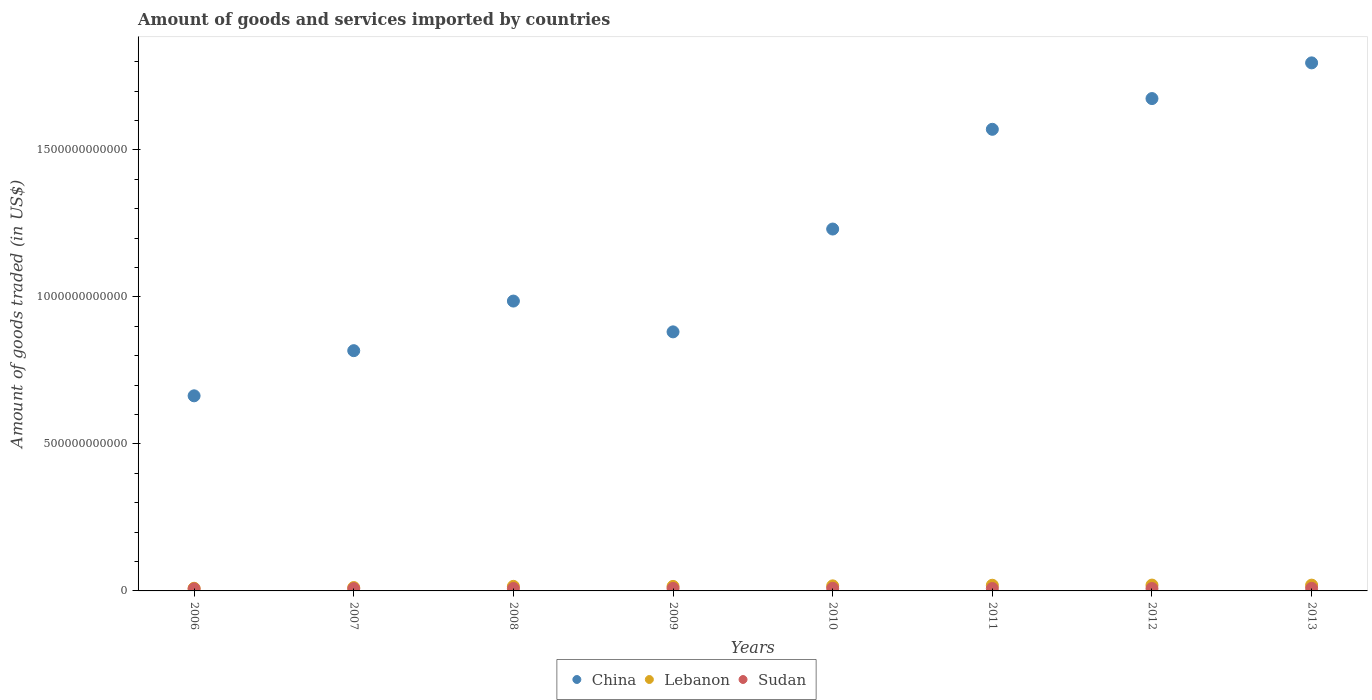How many different coloured dotlines are there?
Your answer should be very brief. 3. Is the number of dotlines equal to the number of legend labels?
Keep it short and to the point. Yes. What is the total amount of goods and services imported in Sudan in 2007?
Make the answer very short. 7.72e+09. Across all years, what is the maximum total amount of goods and services imported in Sudan?
Your response must be concise. 8.84e+09. Across all years, what is the minimum total amount of goods and services imported in Lebanon?
Your answer should be very brief. 9.03e+09. In which year was the total amount of goods and services imported in Lebanon minimum?
Offer a very short reply. 2006. What is the total total amount of goods and services imported in China in the graph?
Provide a succinct answer. 9.62e+12. What is the difference between the total amount of goods and services imported in China in 2010 and that in 2013?
Provide a short and direct response. -5.65e+11. What is the difference between the total amount of goods and services imported in China in 2009 and the total amount of goods and services imported in Sudan in 2008?
Your answer should be very brief. 8.73e+11. What is the average total amount of goods and services imported in Lebanon per year?
Keep it short and to the point. 1.59e+1. In the year 2006, what is the difference between the total amount of goods and services imported in Lebanon and total amount of goods and services imported in China?
Keep it short and to the point. -6.54e+11. In how many years, is the total amount of goods and services imported in Sudan greater than 600000000000 US$?
Make the answer very short. 0. What is the ratio of the total amount of goods and services imported in Lebanon in 2010 to that in 2012?
Your response must be concise. 0.87. Is the total amount of goods and services imported in Sudan in 2011 less than that in 2012?
Your response must be concise. No. What is the difference between the highest and the second highest total amount of goods and services imported in Lebanon?
Offer a very short reply. 1.67e+08. What is the difference between the highest and the lowest total amount of goods and services imported in China?
Offer a terse response. 1.13e+12. In how many years, is the total amount of goods and services imported in China greater than the average total amount of goods and services imported in China taken over all years?
Keep it short and to the point. 4. Is the sum of the total amount of goods and services imported in Lebanon in 2009 and 2011 greater than the maximum total amount of goods and services imported in China across all years?
Keep it short and to the point. No. Is it the case that in every year, the sum of the total amount of goods and services imported in China and total amount of goods and services imported in Lebanon  is greater than the total amount of goods and services imported in Sudan?
Offer a terse response. Yes. Does the total amount of goods and services imported in China monotonically increase over the years?
Make the answer very short. No. Is the total amount of goods and services imported in Lebanon strictly less than the total amount of goods and services imported in China over the years?
Provide a succinct answer. Yes. How many dotlines are there?
Provide a short and direct response. 3. How many years are there in the graph?
Your answer should be very brief. 8. What is the difference between two consecutive major ticks on the Y-axis?
Your response must be concise. 5.00e+11. Does the graph contain any zero values?
Keep it short and to the point. No. How many legend labels are there?
Your answer should be compact. 3. What is the title of the graph?
Your answer should be compact. Amount of goods and services imported by countries. Does "Maldives" appear as one of the legend labels in the graph?
Provide a succinct answer. No. What is the label or title of the Y-axis?
Your response must be concise. Amount of goods traded (in US$). What is the Amount of goods traded (in US$) of China in 2006?
Give a very brief answer. 6.64e+11. What is the Amount of goods traded (in US$) of Lebanon in 2006?
Your answer should be very brief. 9.03e+09. What is the Amount of goods traded (in US$) in Sudan in 2006?
Ensure brevity in your answer.  7.10e+09. What is the Amount of goods traded (in US$) of China in 2007?
Your answer should be compact. 8.17e+11. What is the Amount of goods traded (in US$) of Lebanon in 2007?
Your answer should be compact. 1.15e+1. What is the Amount of goods traded (in US$) of Sudan in 2007?
Your answer should be compact. 7.72e+09. What is the Amount of goods traded (in US$) in China in 2008?
Ensure brevity in your answer.  9.86e+11. What is the Amount of goods traded (in US$) of Lebanon in 2008?
Offer a very short reply. 1.55e+1. What is the Amount of goods traded (in US$) in Sudan in 2008?
Offer a very short reply. 8.23e+09. What is the Amount of goods traded (in US$) of China in 2009?
Your answer should be compact. 8.81e+11. What is the Amount of goods traded (in US$) in Lebanon in 2009?
Your response must be concise. 1.54e+1. What is the Amount of goods traded (in US$) in Sudan in 2009?
Your answer should be compact. 8.53e+09. What is the Amount of goods traded (in US$) in China in 2010?
Your response must be concise. 1.23e+12. What is the Amount of goods traded (in US$) in Lebanon in 2010?
Give a very brief answer. 1.72e+1. What is the Amount of goods traded (in US$) in Sudan in 2010?
Ensure brevity in your answer.  8.84e+09. What is the Amount of goods traded (in US$) in China in 2011?
Make the answer very short. 1.57e+12. What is the Amount of goods traded (in US$) of Lebanon in 2011?
Provide a short and direct response. 1.93e+1. What is the Amount of goods traded (in US$) of Sudan in 2011?
Your answer should be very brief. 8.13e+09. What is the Amount of goods traded (in US$) in China in 2012?
Give a very brief answer. 1.67e+12. What is the Amount of goods traded (in US$) of Lebanon in 2012?
Provide a short and direct response. 1.98e+1. What is the Amount of goods traded (in US$) of Sudan in 2012?
Offer a terse response. 8.12e+09. What is the Amount of goods traded (in US$) of China in 2013?
Your response must be concise. 1.80e+12. What is the Amount of goods traded (in US$) in Lebanon in 2013?
Offer a terse response. 1.97e+1. What is the Amount of goods traded (in US$) in Sudan in 2013?
Your answer should be very brief. 8.73e+09. Across all years, what is the maximum Amount of goods traded (in US$) of China?
Provide a succinct answer. 1.80e+12. Across all years, what is the maximum Amount of goods traded (in US$) in Lebanon?
Provide a short and direct response. 1.98e+1. Across all years, what is the maximum Amount of goods traded (in US$) of Sudan?
Provide a short and direct response. 8.84e+09. Across all years, what is the minimum Amount of goods traded (in US$) of China?
Make the answer very short. 6.64e+11. Across all years, what is the minimum Amount of goods traded (in US$) in Lebanon?
Provide a short and direct response. 9.03e+09. Across all years, what is the minimum Amount of goods traded (in US$) of Sudan?
Offer a very short reply. 7.10e+09. What is the total Amount of goods traded (in US$) in China in the graph?
Give a very brief answer. 9.62e+12. What is the total Amount of goods traded (in US$) in Lebanon in the graph?
Offer a very short reply. 1.27e+11. What is the total Amount of goods traded (in US$) in Sudan in the graph?
Your response must be concise. 6.54e+1. What is the difference between the Amount of goods traded (in US$) of China in 2006 and that in 2007?
Your answer should be very brief. -1.54e+11. What is the difference between the Amount of goods traded (in US$) in Lebanon in 2006 and that in 2007?
Keep it short and to the point. -2.44e+09. What is the difference between the Amount of goods traded (in US$) of Sudan in 2006 and that in 2007?
Provide a short and direct response. -6.18e+08. What is the difference between the Amount of goods traded (in US$) in China in 2006 and that in 2008?
Give a very brief answer. -3.22e+11. What is the difference between the Amount of goods traded (in US$) in Lebanon in 2006 and that in 2008?
Provide a short and direct response. -6.51e+09. What is the difference between the Amount of goods traded (in US$) in Sudan in 2006 and that in 2008?
Offer a terse response. -1.12e+09. What is the difference between the Amount of goods traded (in US$) of China in 2006 and that in 2009?
Provide a succinct answer. -2.17e+11. What is the difference between the Amount of goods traded (in US$) of Lebanon in 2006 and that in 2009?
Provide a short and direct response. -6.37e+09. What is the difference between the Amount of goods traded (in US$) of Sudan in 2006 and that in 2009?
Offer a very short reply. -1.42e+09. What is the difference between the Amount of goods traded (in US$) of China in 2006 and that in 2010?
Ensure brevity in your answer.  -5.67e+11. What is the difference between the Amount of goods traded (in US$) in Lebanon in 2006 and that in 2010?
Offer a very short reply. -8.16e+09. What is the difference between the Amount of goods traded (in US$) in Sudan in 2006 and that in 2010?
Offer a terse response. -1.73e+09. What is the difference between the Amount of goods traded (in US$) in China in 2006 and that in 2011?
Your answer should be very brief. -9.06e+11. What is the difference between the Amount of goods traded (in US$) of Lebanon in 2006 and that in 2011?
Provide a short and direct response. -1.03e+1. What is the difference between the Amount of goods traded (in US$) of Sudan in 2006 and that in 2011?
Your response must be concise. -1.02e+09. What is the difference between the Amount of goods traded (in US$) in China in 2006 and that in 2012?
Your answer should be very brief. -1.01e+12. What is the difference between the Amount of goods traded (in US$) of Lebanon in 2006 and that in 2012?
Offer a very short reply. -1.08e+1. What is the difference between the Amount of goods traded (in US$) of Sudan in 2006 and that in 2012?
Make the answer very short. -1.02e+09. What is the difference between the Amount of goods traded (in US$) of China in 2006 and that in 2013?
Make the answer very short. -1.13e+12. What is the difference between the Amount of goods traded (in US$) in Lebanon in 2006 and that in 2013?
Offer a terse response. -1.06e+1. What is the difference between the Amount of goods traded (in US$) of Sudan in 2006 and that in 2013?
Provide a succinct answer. -1.62e+09. What is the difference between the Amount of goods traded (in US$) of China in 2007 and that in 2008?
Make the answer very short. -1.69e+11. What is the difference between the Amount of goods traded (in US$) of Lebanon in 2007 and that in 2008?
Your response must be concise. -4.07e+09. What is the difference between the Amount of goods traded (in US$) of Sudan in 2007 and that in 2008?
Your response must be concise. -5.07e+08. What is the difference between the Amount of goods traded (in US$) in China in 2007 and that in 2009?
Your response must be concise. -6.39e+1. What is the difference between the Amount of goods traded (in US$) in Lebanon in 2007 and that in 2009?
Keep it short and to the point. -3.93e+09. What is the difference between the Amount of goods traded (in US$) in Sudan in 2007 and that in 2009?
Your response must be concise. -8.06e+08. What is the difference between the Amount of goods traded (in US$) of China in 2007 and that in 2010?
Offer a terse response. -4.14e+11. What is the difference between the Amount of goods traded (in US$) in Lebanon in 2007 and that in 2010?
Make the answer very short. -5.72e+09. What is the difference between the Amount of goods traded (in US$) in Sudan in 2007 and that in 2010?
Your response must be concise. -1.12e+09. What is the difference between the Amount of goods traded (in US$) in China in 2007 and that in 2011?
Make the answer very short. -7.53e+11. What is the difference between the Amount of goods traded (in US$) in Lebanon in 2007 and that in 2011?
Your response must be concise. -7.84e+09. What is the difference between the Amount of goods traded (in US$) in Sudan in 2007 and that in 2011?
Provide a short and direct response. -4.05e+08. What is the difference between the Amount of goods traded (in US$) in China in 2007 and that in 2012?
Your answer should be compact. -8.57e+11. What is the difference between the Amount of goods traded (in US$) in Lebanon in 2007 and that in 2012?
Offer a terse response. -8.38e+09. What is the difference between the Amount of goods traded (in US$) of Sudan in 2007 and that in 2012?
Provide a succinct answer. -4.00e+08. What is the difference between the Amount of goods traded (in US$) in China in 2007 and that in 2013?
Offer a terse response. -9.79e+11. What is the difference between the Amount of goods traded (in US$) of Lebanon in 2007 and that in 2013?
Your answer should be very brief. -8.21e+09. What is the difference between the Amount of goods traded (in US$) of Sudan in 2007 and that in 2013?
Your answer should be very brief. -1.01e+09. What is the difference between the Amount of goods traded (in US$) of China in 2008 and that in 2009?
Keep it short and to the point. 1.05e+11. What is the difference between the Amount of goods traded (in US$) in Lebanon in 2008 and that in 2009?
Your answer should be very brief. 1.36e+08. What is the difference between the Amount of goods traded (in US$) of Sudan in 2008 and that in 2009?
Give a very brief answer. -2.99e+08. What is the difference between the Amount of goods traded (in US$) of China in 2008 and that in 2010?
Your answer should be very brief. -2.45e+11. What is the difference between the Amount of goods traded (in US$) in Lebanon in 2008 and that in 2010?
Your response must be concise. -1.66e+09. What is the difference between the Amount of goods traded (in US$) in Sudan in 2008 and that in 2010?
Make the answer very short. -6.10e+08. What is the difference between the Amount of goods traded (in US$) in China in 2008 and that in 2011?
Make the answer very short. -5.84e+11. What is the difference between the Amount of goods traded (in US$) in Lebanon in 2008 and that in 2011?
Your response must be concise. -3.77e+09. What is the difference between the Amount of goods traded (in US$) in Sudan in 2008 and that in 2011?
Your answer should be very brief. 1.02e+08. What is the difference between the Amount of goods traded (in US$) of China in 2008 and that in 2012?
Keep it short and to the point. -6.89e+11. What is the difference between the Amount of goods traded (in US$) of Lebanon in 2008 and that in 2012?
Provide a succinct answer. -4.31e+09. What is the difference between the Amount of goods traded (in US$) of Sudan in 2008 and that in 2012?
Provide a short and direct response. 1.07e+08. What is the difference between the Amount of goods traded (in US$) of China in 2008 and that in 2013?
Provide a short and direct response. -8.10e+11. What is the difference between the Amount of goods traded (in US$) in Lebanon in 2008 and that in 2013?
Offer a very short reply. -4.14e+09. What is the difference between the Amount of goods traded (in US$) of Sudan in 2008 and that in 2013?
Provide a succinct answer. -4.99e+08. What is the difference between the Amount of goods traded (in US$) in China in 2009 and that in 2010?
Give a very brief answer. -3.50e+11. What is the difference between the Amount of goods traded (in US$) of Lebanon in 2009 and that in 2010?
Give a very brief answer. -1.79e+09. What is the difference between the Amount of goods traded (in US$) of Sudan in 2009 and that in 2010?
Make the answer very short. -3.11e+08. What is the difference between the Amount of goods traded (in US$) in China in 2009 and that in 2011?
Ensure brevity in your answer.  -6.89e+11. What is the difference between the Amount of goods traded (in US$) of Lebanon in 2009 and that in 2011?
Offer a terse response. -3.91e+09. What is the difference between the Amount of goods traded (in US$) in Sudan in 2009 and that in 2011?
Your answer should be very brief. 4.00e+08. What is the difference between the Amount of goods traded (in US$) of China in 2009 and that in 2012?
Ensure brevity in your answer.  -7.93e+11. What is the difference between the Amount of goods traded (in US$) in Lebanon in 2009 and that in 2012?
Provide a short and direct response. -4.45e+09. What is the difference between the Amount of goods traded (in US$) of Sudan in 2009 and that in 2012?
Your answer should be compact. 4.05e+08. What is the difference between the Amount of goods traded (in US$) of China in 2009 and that in 2013?
Your answer should be very brief. -9.15e+11. What is the difference between the Amount of goods traded (in US$) in Lebanon in 2009 and that in 2013?
Offer a terse response. -4.28e+09. What is the difference between the Amount of goods traded (in US$) of Sudan in 2009 and that in 2013?
Your answer should be very brief. -2.00e+08. What is the difference between the Amount of goods traded (in US$) in China in 2010 and that in 2011?
Keep it short and to the point. -3.39e+11. What is the difference between the Amount of goods traded (in US$) of Lebanon in 2010 and that in 2011?
Provide a succinct answer. -2.12e+09. What is the difference between the Amount of goods traded (in US$) in Sudan in 2010 and that in 2011?
Keep it short and to the point. 7.12e+08. What is the difference between the Amount of goods traded (in US$) of China in 2010 and that in 2012?
Your response must be concise. -4.44e+11. What is the difference between the Amount of goods traded (in US$) in Lebanon in 2010 and that in 2012?
Your response must be concise. -2.65e+09. What is the difference between the Amount of goods traded (in US$) of Sudan in 2010 and that in 2012?
Your response must be concise. 7.17e+08. What is the difference between the Amount of goods traded (in US$) of China in 2010 and that in 2013?
Ensure brevity in your answer.  -5.65e+11. What is the difference between the Amount of goods traded (in US$) of Lebanon in 2010 and that in 2013?
Offer a terse response. -2.48e+09. What is the difference between the Amount of goods traded (in US$) in Sudan in 2010 and that in 2013?
Ensure brevity in your answer.  1.11e+08. What is the difference between the Amount of goods traded (in US$) in China in 2011 and that in 2012?
Keep it short and to the point. -1.05e+11. What is the difference between the Amount of goods traded (in US$) in Lebanon in 2011 and that in 2012?
Give a very brief answer. -5.35e+08. What is the difference between the Amount of goods traded (in US$) in Sudan in 2011 and that in 2012?
Offer a terse response. 4.88e+06. What is the difference between the Amount of goods traded (in US$) of China in 2011 and that in 2013?
Offer a terse response. -2.26e+11. What is the difference between the Amount of goods traded (in US$) in Lebanon in 2011 and that in 2013?
Provide a succinct answer. -3.68e+08. What is the difference between the Amount of goods traded (in US$) in Sudan in 2011 and that in 2013?
Your answer should be very brief. -6.00e+08. What is the difference between the Amount of goods traded (in US$) in China in 2012 and that in 2013?
Provide a succinct answer. -1.21e+11. What is the difference between the Amount of goods traded (in US$) in Lebanon in 2012 and that in 2013?
Provide a short and direct response. 1.67e+08. What is the difference between the Amount of goods traded (in US$) of Sudan in 2012 and that in 2013?
Keep it short and to the point. -6.05e+08. What is the difference between the Amount of goods traded (in US$) of China in 2006 and the Amount of goods traded (in US$) of Lebanon in 2007?
Ensure brevity in your answer.  6.52e+11. What is the difference between the Amount of goods traded (in US$) of China in 2006 and the Amount of goods traded (in US$) of Sudan in 2007?
Your response must be concise. 6.56e+11. What is the difference between the Amount of goods traded (in US$) in Lebanon in 2006 and the Amount of goods traded (in US$) in Sudan in 2007?
Offer a very short reply. 1.30e+09. What is the difference between the Amount of goods traded (in US$) of China in 2006 and the Amount of goods traded (in US$) of Lebanon in 2008?
Your answer should be very brief. 6.48e+11. What is the difference between the Amount of goods traded (in US$) in China in 2006 and the Amount of goods traded (in US$) in Sudan in 2008?
Offer a terse response. 6.55e+11. What is the difference between the Amount of goods traded (in US$) in Lebanon in 2006 and the Amount of goods traded (in US$) in Sudan in 2008?
Your answer should be compact. 7.96e+08. What is the difference between the Amount of goods traded (in US$) in China in 2006 and the Amount of goods traded (in US$) in Lebanon in 2009?
Give a very brief answer. 6.48e+11. What is the difference between the Amount of goods traded (in US$) of China in 2006 and the Amount of goods traded (in US$) of Sudan in 2009?
Make the answer very short. 6.55e+11. What is the difference between the Amount of goods traded (in US$) of Lebanon in 2006 and the Amount of goods traded (in US$) of Sudan in 2009?
Your response must be concise. 4.97e+08. What is the difference between the Amount of goods traded (in US$) in China in 2006 and the Amount of goods traded (in US$) in Lebanon in 2010?
Provide a succinct answer. 6.46e+11. What is the difference between the Amount of goods traded (in US$) in China in 2006 and the Amount of goods traded (in US$) in Sudan in 2010?
Provide a short and direct response. 6.55e+11. What is the difference between the Amount of goods traded (in US$) in Lebanon in 2006 and the Amount of goods traded (in US$) in Sudan in 2010?
Give a very brief answer. 1.86e+08. What is the difference between the Amount of goods traded (in US$) of China in 2006 and the Amount of goods traded (in US$) of Lebanon in 2011?
Ensure brevity in your answer.  6.44e+11. What is the difference between the Amount of goods traded (in US$) in China in 2006 and the Amount of goods traded (in US$) in Sudan in 2011?
Offer a terse response. 6.55e+11. What is the difference between the Amount of goods traded (in US$) in Lebanon in 2006 and the Amount of goods traded (in US$) in Sudan in 2011?
Make the answer very short. 8.97e+08. What is the difference between the Amount of goods traded (in US$) of China in 2006 and the Amount of goods traded (in US$) of Lebanon in 2012?
Your response must be concise. 6.44e+11. What is the difference between the Amount of goods traded (in US$) of China in 2006 and the Amount of goods traded (in US$) of Sudan in 2012?
Provide a short and direct response. 6.55e+11. What is the difference between the Amount of goods traded (in US$) in Lebanon in 2006 and the Amount of goods traded (in US$) in Sudan in 2012?
Offer a terse response. 9.02e+08. What is the difference between the Amount of goods traded (in US$) of China in 2006 and the Amount of goods traded (in US$) of Lebanon in 2013?
Ensure brevity in your answer.  6.44e+11. What is the difference between the Amount of goods traded (in US$) of China in 2006 and the Amount of goods traded (in US$) of Sudan in 2013?
Offer a terse response. 6.55e+11. What is the difference between the Amount of goods traded (in US$) in Lebanon in 2006 and the Amount of goods traded (in US$) in Sudan in 2013?
Provide a succinct answer. 2.97e+08. What is the difference between the Amount of goods traded (in US$) of China in 2007 and the Amount of goods traded (in US$) of Lebanon in 2008?
Make the answer very short. 8.02e+11. What is the difference between the Amount of goods traded (in US$) of China in 2007 and the Amount of goods traded (in US$) of Sudan in 2008?
Keep it short and to the point. 8.09e+11. What is the difference between the Amount of goods traded (in US$) of Lebanon in 2007 and the Amount of goods traded (in US$) of Sudan in 2008?
Your response must be concise. 3.23e+09. What is the difference between the Amount of goods traded (in US$) in China in 2007 and the Amount of goods traded (in US$) in Lebanon in 2009?
Your response must be concise. 8.02e+11. What is the difference between the Amount of goods traded (in US$) in China in 2007 and the Amount of goods traded (in US$) in Sudan in 2009?
Your answer should be very brief. 8.09e+11. What is the difference between the Amount of goods traded (in US$) in Lebanon in 2007 and the Amount of goods traded (in US$) in Sudan in 2009?
Your answer should be compact. 2.94e+09. What is the difference between the Amount of goods traded (in US$) of China in 2007 and the Amount of goods traded (in US$) of Lebanon in 2010?
Ensure brevity in your answer.  8.00e+11. What is the difference between the Amount of goods traded (in US$) of China in 2007 and the Amount of goods traded (in US$) of Sudan in 2010?
Your answer should be very brief. 8.08e+11. What is the difference between the Amount of goods traded (in US$) of Lebanon in 2007 and the Amount of goods traded (in US$) of Sudan in 2010?
Keep it short and to the point. 2.62e+09. What is the difference between the Amount of goods traded (in US$) in China in 2007 and the Amount of goods traded (in US$) in Lebanon in 2011?
Give a very brief answer. 7.98e+11. What is the difference between the Amount of goods traded (in US$) of China in 2007 and the Amount of goods traded (in US$) of Sudan in 2011?
Your answer should be very brief. 8.09e+11. What is the difference between the Amount of goods traded (in US$) in Lebanon in 2007 and the Amount of goods traded (in US$) in Sudan in 2011?
Provide a short and direct response. 3.34e+09. What is the difference between the Amount of goods traded (in US$) of China in 2007 and the Amount of goods traded (in US$) of Lebanon in 2012?
Provide a succinct answer. 7.97e+11. What is the difference between the Amount of goods traded (in US$) in China in 2007 and the Amount of goods traded (in US$) in Sudan in 2012?
Your answer should be compact. 8.09e+11. What is the difference between the Amount of goods traded (in US$) in Lebanon in 2007 and the Amount of goods traded (in US$) in Sudan in 2012?
Give a very brief answer. 3.34e+09. What is the difference between the Amount of goods traded (in US$) in China in 2007 and the Amount of goods traded (in US$) in Lebanon in 2013?
Your response must be concise. 7.97e+11. What is the difference between the Amount of goods traded (in US$) in China in 2007 and the Amount of goods traded (in US$) in Sudan in 2013?
Offer a very short reply. 8.08e+11. What is the difference between the Amount of goods traded (in US$) in Lebanon in 2007 and the Amount of goods traded (in US$) in Sudan in 2013?
Give a very brief answer. 2.74e+09. What is the difference between the Amount of goods traded (in US$) of China in 2008 and the Amount of goods traded (in US$) of Lebanon in 2009?
Your response must be concise. 9.70e+11. What is the difference between the Amount of goods traded (in US$) in China in 2008 and the Amount of goods traded (in US$) in Sudan in 2009?
Your answer should be very brief. 9.77e+11. What is the difference between the Amount of goods traded (in US$) in Lebanon in 2008 and the Amount of goods traded (in US$) in Sudan in 2009?
Offer a terse response. 7.00e+09. What is the difference between the Amount of goods traded (in US$) in China in 2008 and the Amount of goods traded (in US$) in Lebanon in 2010?
Make the answer very short. 9.69e+11. What is the difference between the Amount of goods traded (in US$) in China in 2008 and the Amount of goods traded (in US$) in Sudan in 2010?
Keep it short and to the point. 9.77e+11. What is the difference between the Amount of goods traded (in US$) in Lebanon in 2008 and the Amount of goods traded (in US$) in Sudan in 2010?
Provide a succinct answer. 6.69e+09. What is the difference between the Amount of goods traded (in US$) in China in 2008 and the Amount of goods traded (in US$) in Lebanon in 2011?
Your answer should be very brief. 9.66e+11. What is the difference between the Amount of goods traded (in US$) in China in 2008 and the Amount of goods traded (in US$) in Sudan in 2011?
Make the answer very short. 9.78e+11. What is the difference between the Amount of goods traded (in US$) of Lebanon in 2008 and the Amount of goods traded (in US$) of Sudan in 2011?
Make the answer very short. 7.40e+09. What is the difference between the Amount of goods traded (in US$) of China in 2008 and the Amount of goods traded (in US$) of Lebanon in 2012?
Make the answer very short. 9.66e+11. What is the difference between the Amount of goods traded (in US$) in China in 2008 and the Amount of goods traded (in US$) in Sudan in 2012?
Your answer should be very brief. 9.78e+11. What is the difference between the Amount of goods traded (in US$) of Lebanon in 2008 and the Amount of goods traded (in US$) of Sudan in 2012?
Offer a very short reply. 7.41e+09. What is the difference between the Amount of goods traded (in US$) of China in 2008 and the Amount of goods traded (in US$) of Lebanon in 2013?
Make the answer very short. 9.66e+11. What is the difference between the Amount of goods traded (in US$) of China in 2008 and the Amount of goods traded (in US$) of Sudan in 2013?
Make the answer very short. 9.77e+11. What is the difference between the Amount of goods traded (in US$) in Lebanon in 2008 and the Amount of goods traded (in US$) in Sudan in 2013?
Give a very brief answer. 6.80e+09. What is the difference between the Amount of goods traded (in US$) in China in 2009 and the Amount of goods traded (in US$) in Lebanon in 2010?
Your answer should be very brief. 8.64e+11. What is the difference between the Amount of goods traded (in US$) of China in 2009 and the Amount of goods traded (in US$) of Sudan in 2010?
Your response must be concise. 8.72e+11. What is the difference between the Amount of goods traded (in US$) in Lebanon in 2009 and the Amount of goods traded (in US$) in Sudan in 2010?
Offer a very short reply. 6.55e+09. What is the difference between the Amount of goods traded (in US$) in China in 2009 and the Amount of goods traded (in US$) in Lebanon in 2011?
Ensure brevity in your answer.  8.62e+11. What is the difference between the Amount of goods traded (in US$) of China in 2009 and the Amount of goods traded (in US$) of Sudan in 2011?
Ensure brevity in your answer.  8.73e+11. What is the difference between the Amount of goods traded (in US$) in Lebanon in 2009 and the Amount of goods traded (in US$) in Sudan in 2011?
Offer a terse response. 7.27e+09. What is the difference between the Amount of goods traded (in US$) of China in 2009 and the Amount of goods traded (in US$) of Lebanon in 2012?
Provide a succinct answer. 8.61e+11. What is the difference between the Amount of goods traded (in US$) of China in 2009 and the Amount of goods traded (in US$) of Sudan in 2012?
Give a very brief answer. 8.73e+11. What is the difference between the Amount of goods traded (in US$) in Lebanon in 2009 and the Amount of goods traded (in US$) in Sudan in 2012?
Provide a succinct answer. 7.27e+09. What is the difference between the Amount of goods traded (in US$) in China in 2009 and the Amount of goods traded (in US$) in Lebanon in 2013?
Provide a short and direct response. 8.61e+11. What is the difference between the Amount of goods traded (in US$) in China in 2009 and the Amount of goods traded (in US$) in Sudan in 2013?
Offer a very short reply. 8.72e+11. What is the difference between the Amount of goods traded (in US$) in Lebanon in 2009 and the Amount of goods traded (in US$) in Sudan in 2013?
Keep it short and to the point. 6.67e+09. What is the difference between the Amount of goods traded (in US$) in China in 2010 and the Amount of goods traded (in US$) in Lebanon in 2011?
Your answer should be very brief. 1.21e+12. What is the difference between the Amount of goods traded (in US$) of China in 2010 and the Amount of goods traded (in US$) of Sudan in 2011?
Ensure brevity in your answer.  1.22e+12. What is the difference between the Amount of goods traded (in US$) of Lebanon in 2010 and the Amount of goods traded (in US$) of Sudan in 2011?
Provide a succinct answer. 9.06e+09. What is the difference between the Amount of goods traded (in US$) in China in 2010 and the Amount of goods traded (in US$) in Lebanon in 2012?
Offer a very short reply. 1.21e+12. What is the difference between the Amount of goods traded (in US$) of China in 2010 and the Amount of goods traded (in US$) of Sudan in 2012?
Give a very brief answer. 1.22e+12. What is the difference between the Amount of goods traded (in US$) of Lebanon in 2010 and the Amount of goods traded (in US$) of Sudan in 2012?
Your response must be concise. 9.07e+09. What is the difference between the Amount of goods traded (in US$) in China in 2010 and the Amount of goods traded (in US$) in Lebanon in 2013?
Offer a terse response. 1.21e+12. What is the difference between the Amount of goods traded (in US$) of China in 2010 and the Amount of goods traded (in US$) of Sudan in 2013?
Your response must be concise. 1.22e+12. What is the difference between the Amount of goods traded (in US$) in Lebanon in 2010 and the Amount of goods traded (in US$) in Sudan in 2013?
Provide a short and direct response. 8.46e+09. What is the difference between the Amount of goods traded (in US$) of China in 2011 and the Amount of goods traded (in US$) of Lebanon in 2012?
Your answer should be compact. 1.55e+12. What is the difference between the Amount of goods traded (in US$) of China in 2011 and the Amount of goods traded (in US$) of Sudan in 2012?
Give a very brief answer. 1.56e+12. What is the difference between the Amount of goods traded (in US$) in Lebanon in 2011 and the Amount of goods traded (in US$) in Sudan in 2012?
Offer a terse response. 1.12e+1. What is the difference between the Amount of goods traded (in US$) in China in 2011 and the Amount of goods traded (in US$) in Lebanon in 2013?
Offer a very short reply. 1.55e+12. What is the difference between the Amount of goods traded (in US$) in China in 2011 and the Amount of goods traded (in US$) in Sudan in 2013?
Ensure brevity in your answer.  1.56e+12. What is the difference between the Amount of goods traded (in US$) in Lebanon in 2011 and the Amount of goods traded (in US$) in Sudan in 2013?
Your answer should be compact. 1.06e+1. What is the difference between the Amount of goods traded (in US$) in China in 2012 and the Amount of goods traded (in US$) in Lebanon in 2013?
Provide a short and direct response. 1.65e+12. What is the difference between the Amount of goods traded (in US$) of China in 2012 and the Amount of goods traded (in US$) of Sudan in 2013?
Give a very brief answer. 1.67e+12. What is the difference between the Amount of goods traded (in US$) of Lebanon in 2012 and the Amount of goods traded (in US$) of Sudan in 2013?
Provide a succinct answer. 1.11e+1. What is the average Amount of goods traded (in US$) of China per year?
Provide a succinct answer. 1.20e+12. What is the average Amount of goods traded (in US$) of Lebanon per year?
Ensure brevity in your answer.  1.59e+1. What is the average Amount of goods traded (in US$) in Sudan per year?
Offer a terse response. 8.18e+09. In the year 2006, what is the difference between the Amount of goods traded (in US$) in China and Amount of goods traded (in US$) in Lebanon?
Your answer should be very brief. 6.54e+11. In the year 2006, what is the difference between the Amount of goods traded (in US$) of China and Amount of goods traded (in US$) of Sudan?
Provide a short and direct response. 6.56e+11. In the year 2006, what is the difference between the Amount of goods traded (in US$) of Lebanon and Amount of goods traded (in US$) of Sudan?
Give a very brief answer. 1.92e+09. In the year 2007, what is the difference between the Amount of goods traded (in US$) in China and Amount of goods traded (in US$) in Lebanon?
Give a very brief answer. 8.06e+11. In the year 2007, what is the difference between the Amount of goods traded (in US$) of China and Amount of goods traded (in US$) of Sudan?
Keep it short and to the point. 8.09e+11. In the year 2007, what is the difference between the Amount of goods traded (in US$) of Lebanon and Amount of goods traded (in US$) of Sudan?
Make the answer very short. 3.74e+09. In the year 2008, what is the difference between the Amount of goods traded (in US$) in China and Amount of goods traded (in US$) in Lebanon?
Offer a very short reply. 9.70e+11. In the year 2008, what is the difference between the Amount of goods traded (in US$) in China and Amount of goods traded (in US$) in Sudan?
Give a very brief answer. 9.77e+11. In the year 2008, what is the difference between the Amount of goods traded (in US$) of Lebanon and Amount of goods traded (in US$) of Sudan?
Offer a very short reply. 7.30e+09. In the year 2009, what is the difference between the Amount of goods traded (in US$) in China and Amount of goods traded (in US$) in Lebanon?
Provide a succinct answer. 8.66e+11. In the year 2009, what is the difference between the Amount of goods traded (in US$) of China and Amount of goods traded (in US$) of Sudan?
Make the answer very short. 8.72e+11. In the year 2009, what is the difference between the Amount of goods traded (in US$) of Lebanon and Amount of goods traded (in US$) of Sudan?
Provide a succinct answer. 6.87e+09. In the year 2010, what is the difference between the Amount of goods traded (in US$) of China and Amount of goods traded (in US$) of Lebanon?
Offer a terse response. 1.21e+12. In the year 2010, what is the difference between the Amount of goods traded (in US$) in China and Amount of goods traded (in US$) in Sudan?
Provide a short and direct response. 1.22e+12. In the year 2010, what is the difference between the Amount of goods traded (in US$) of Lebanon and Amount of goods traded (in US$) of Sudan?
Your response must be concise. 8.35e+09. In the year 2011, what is the difference between the Amount of goods traded (in US$) of China and Amount of goods traded (in US$) of Lebanon?
Keep it short and to the point. 1.55e+12. In the year 2011, what is the difference between the Amount of goods traded (in US$) of China and Amount of goods traded (in US$) of Sudan?
Offer a terse response. 1.56e+12. In the year 2011, what is the difference between the Amount of goods traded (in US$) in Lebanon and Amount of goods traded (in US$) in Sudan?
Keep it short and to the point. 1.12e+1. In the year 2012, what is the difference between the Amount of goods traded (in US$) of China and Amount of goods traded (in US$) of Lebanon?
Give a very brief answer. 1.65e+12. In the year 2012, what is the difference between the Amount of goods traded (in US$) of China and Amount of goods traded (in US$) of Sudan?
Make the answer very short. 1.67e+12. In the year 2012, what is the difference between the Amount of goods traded (in US$) of Lebanon and Amount of goods traded (in US$) of Sudan?
Offer a very short reply. 1.17e+1. In the year 2013, what is the difference between the Amount of goods traded (in US$) in China and Amount of goods traded (in US$) in Lebanon?
Give a very brief answer. 1.78e+12. In the year 2013, what is the difference between the Amount of goods traded (in US$) in China and Amount of goods traded (in US$) in Sudan?
Your answer should be compact. 1.79e+12. In the year 2013, what is the difference between the Amount of goods traded (in US$) of Lebanon and Amount of goods traded (in US$) of Sudan?
Provide a short and direct response. 1.09e+1. What is the ratio of the Amount of goods traded (in US$) in China in 2006 to that in 2007?
Your response must be concise. 0.81. What is the ratio of the Amount of goods traded (in US$) of Lebanon in 2006 to that in 2007?
Offer a very short reply. 0.79. What is the ratio of the Amount of goods traded (in US$) of China in 2006 to that in 2008?
Offer a terse response. 0.67. What is the ratio of the Amount of goods traded (in US$) of Lebanon in 2006 to that in 2008?
Your answer should be very brief. 0.58. What is the ratio of the Amount of goods traded (in US$) of Sudan in 2006 to that in 2008?
Make the answer very short. 0.86. What is the ratio of the Amount of goods traded (in US$) of China in 2006 to that in 2009?
Offer a terse response. 0.75. What is the ratio of the Amount of goods traded (in US$) in Lebanon in 2006 to that in 2009?
Ensure brevity in your answer.  0.59. What is the ratio of the Amount of goods traded (in US$) in Sudan in 2006 to that in 2009?
Give a very brief answer. 0.83. What is the ratio of the Amount of goods traded (in US$) in China in 2006 to that in 2010?
Your answer should be very brief. 0.54. What is the ratio of the Amount of goods traded (in US$) of Lebanon in 2006 to that in 2010?
Your response must be concise. 0.53. What is the ratio of the Amount of goods traded (in US$) in Sudan in 2006 to that in 2010?
Offer a terse response. 0.8. What is the ratio of the Amount of goods traded (in US$) of China in 2006 to that in 2011?
Ensure brevity in your answer.  0.42. What is the ratio of the Amount of goods traded (in US$) of Lebanon in 2006 to that in 2011?
Your answer should be very brief. 0.47. What is the ratio of the Amount of goods traded (in US$) of Sudan in 2006 to that in 2011?
Make the answer very short. 0.87. What is the ratio of the Amount of goods traded (in US$) in China in 2006 to that in 2012?
Provide a succinct answer. 0.4. What is the ratio of the Amount of goods traded (in US$) of Lebanon in 2006 to that in 2012?
Your answer should be very brief. 0.45. What is the ratio of the Amount of goods traded (in US$) of Sudan in 2006 to that in 2012?
Your answer should be compact. 0.87. What is the ratio of the Amount of goods traded (in US$) of China in 2006 to that in 2013?
Provide a succinct answer. 0.37. What is the ratio of the Amount of goods traded (in US$) in Lebanon in 2006 to that in 2013?
Provide a succinct answer. 0.46. What is the ratio of the Amount of goods traded (in US$) of Sudan in 2006 to that in 2013?
Provide a short and direct response. 0.81. What is the ratio of the Amount of goods traded (in US$) in China in 2007 to that in 2008?
Your response must be concise. 0.83. What is the ratio of the Amount of goods traded (in US$) of Lebanon in 2007 to that in 2008?
Provide a short and direct response. 0.74. What is the ratio of the Amount of goods traded (in US$) of Sudan in 2007 to that in 2008?
Keep it short and to the point. 0.94. What is the ratio of the Amount of goods traded (in US$) of China in 2007 to that in 2009?
Your answer should be compact. 0.93. What is the ratio of the Amount of goods traded (in US$) in Lebanon in 2007 to that in 2009?
Provide a short and direct response. 0.74. What is the ratio of the Amount of goods traded (in US$) in Sudan in 2007 to that in 2009?
Provide a succinct answer. 0.91. What is the ratio of the Amount of goods traded (in US$) of China in 2007 to that in 2010?
Your answer should be very brief. 0.66. What is the ratio of the Amount of goods traded (in US$) in Lebanon in 2007 to that in 2010?
Your answer should be compact. 0.67. What is the ratio of the Amount of goods traded (in US$) of Sudan in 2007 to that in 2010?
Your answer should be compact. 0.87. What is the ratio of the Amount of goods traded (in US$) in China in 2007 to that in 2011?
Your response must be concise. 0.52. What is the ratio of the Amount of goods traded (in US$) in Lebanon in 2007 to that in 2011?
Your answer should be very brief. 0.59. What is the ratio of the Amount of goods traded (in US$) in Sudan in 2007 to that in 2011?
Provide a short and direct response. 0.95. What is the ratio of the Amount of goods traded (in US$) in China in 2007 to that in 2012?
Ensure brevity in your answer.  0.49. What is the ratio of the Amount of goods traded (in US$) of Lebanon in 2007 to that in 2012?
Make the answer very short. 0.58. What is the ratio of the Amount of goods traded (in US$) of Sudan in 2007 to that in 2012?
Offer a terse response. 0.95. What is the ratio of the Amount of goods traded (in US$) of China in 2007 to that in 2013?
Offer a very short reply. 0.46. What is the ratio of the Amount of goods traded (in US$) in Lebanon in 2007 to that in 2013?
Keep it short and to the point. 0.58. What is the ratio of the Amount of goods traded (in US$) of Sudan in 2007 to that in 2013?
Keep it short and to the point. 0.88. What is the ratio of the Amount of goods traded (in US$) of China in 2008 to that in 2009?
Provide a succinct answer. 1.12. What is the ratio of the Amount of goods traded (in US$) in Lebanon in 2008 to that in 2009?
Your answer should be very brief. 1.01. What is the ratio of the Amount of goods traded (in US$) of Sudan in 2008 to that in 2009?
Your response must be concise. 0.96. What is the ratio of the Amount of goods traded (in US$) of China in 2008 to that in 2010?
Provide a succinct answer. 0.8. What is the ratio of the Amount of goods traded (in US$) of Lebanon in 2008 to that in 2010?
Offer a very short reply. 0.9. What is the ratio of the Amount of goods traded (in US$) of China in 2008 to that in 2011?
Ensure brevity in your answer.  0.63. What is the ratio of the Amount of goods traded (in US$) of Lebanon in 2008 to that in 2011?
Keep it short and to the point. 0.8. What is the ratio of the Amount of goods traded (in US$) in Sudan in 2008 to that in 2011?
Ensure brevity in your answer.  1.01. What is the ratio of the Amount of goods traded (in US$) in China in 2008 to that in 2012?
Your response must be concise. 0.59. What is the ratio of the Amount of goods traded (in US$) of Lebanon in 2008 to that in 2012?
Your answer should be compact. 0.78. What is the ratio of the Amount of goods traded (in US$) in Sudan in 2008 to that in 2012?
Provide a succinct answer. 1.01. What is the ratio of the Amount of goods traded (in US$) of China in 2008 to that in 2013?
Your response must be concise. 0.55. What is the ratio of the Amount of goods traded (in US$) of Lebanon in 2008 to that in 2013?
Ensure brevity in your answer.  0.79. What is the ratio of the Amount of goods traded (in US$) in Sudan in 2008 to that in 2013?
Keep it short and to the point. 0.94. What is the ratio of the Amount of goods traded (in US$) of China in 2009 to that in 2010?
Ensure brevity in your answer.  0.72. What is the ratio of the Amount of goods traded (in US$) in Lebanon in 2009 to that in 2010?
Your response must be concise. 0.9. What is the ratio of the Amount of goods traded (in US$) in Sudan in 2009 to that in 2010?
Offer a very short reply. 0.96. What is the ratio of the Amount of goods traded (in US$) of China in 2009 to that in 2011?
Your response must be concise. 0.56. What is the ratio of the Amount of goods traded (in US$) of Lebanon in 2009 to that in 2011?
Offer a terse response. 0.8. What is the ratio of the Amount of goods traded (in US$) of Sudan in 2009 to that in 2011?
Offer a terse response. 1.05. What is the ratio of the Amount of goods traded (in US$) in China in 2009 to that in 2012?
Offer a very short reply. 0.53. What is the ratio of the Amount of goods traded (in US$) in Lebanon in 2009 to that in 2012?
Your response must be concise. 0.78. What is the ratio of the Amount of goods traded (in US$) of Sudan in 2009 to that in 2012?
Offer a very short reply. 1.05. What is the ratio of the Amount of goods traded (in US$) of China in 2009 to that in 2013?
Keep it short and to the point. 0.49. What is the ratio of the Amount of goods traded (in US$) in Lebanon in 2009 to that in 2013?
Offer a terse response. 0.78. What is the ratio of the Amount of goods traded (in US$) of Sudan in 2009 to that in 2013?
Offer a very short reply. 0.98. What is the ratio of the Amount of goods traded (in US$) of China in 2010 to that in 2011?
Your answer should be compact. 0.78. What is the ratio of the Amount of goods traded (in US$) in Lebanon in 2010 to that in 2011?
Keep it short and to the point. 0.89. What is the ratio of the Amount of goods traded (in US$) of Sudan in 2010 to that in 2011?
Your response must be concise. 1.09. What is the ratio of the Amount of goods traded (in US$) in China in 2010 to that in 2012?
Offer a terse response. 0.73. What is the ratio of the Amount of goods traded (in US$) of Lebanon in 2010 to that in 2012?
Give a very brief answer. 0.87. What is the ratio of the Amount of goods traded (in US$) of Sudan in 2010 to that in 2012?
Offer a terse response. 1.09. What is the ratio of the Amount of goods traded (in US$) of China in 2010 to that in 2013?
Your answer should be compact. 0.69. What is the ratio of the Amount of goods traded (in US$) of Lebanon in 2010 to that in 2013?
Your answer should be very brief. 0.87. What is the ratio of the Amount of goods traded (in US$) of Sudan in 2010 to that in 2013?
Give a very brief answer. 1.01. What is the ratio of the Amount of goods traded (in US$) of China in 2011 to that in 2012?
Offer a terse response. 0.94. What is the ratio of the Amount of goods traded (in US$) of Lebanon in 2011 to that in 2012?
Your response must be concise. 0.97. What is the ratio of the Amount of goods traded (in US$) in China in 2011 to that in 2013?
Provide a succinct answer. 0.87. What is the ratio of the Amount of goods traded (in US$) in Lebanon in 2011 to that in 2013?
Keep it short and to the point. 0.98. What is the ratio of the Amount of goods traded (in US$) of Sudan in 2011 to that in 2013?
Ensure brevity in your answer.  0.93. What is the ratio of the Amount of goods traded (in US$) in China in 2012 to that in 2013?
Give a very brief answer. 0.93. What is the ratio of the Amount of goods traded (in US$) of Lebanon in 2012 to that in 2013?
Offer a terse response. 1.01. What is the ratio of the Amount of goods traded (in US$) of Sudan in 2012 to that in 2013?
Offer a very short reply. 0.93. What is the difference between the highest and the second highest Amount of goods traded (in US$) of China?
Your response must be concise. 1.21e+11. What is the difference between the highest and the second highest Amount of goods traded (in US$) of Lebanon?
Your answer should be very brief. 1.67e+08. What is the difference between the highest and the second highest Amount of goods traded (in US$) in Sudan?
Your answer should be compact. 1.11e+08. What is the difference between the highest and the lowest Amount of goods traded (in US$) of China?
Ensure brevity in your answer.  1.13e+12. What is the difference between the highest and the lowest Amount of goods traded (in US$) in Lebanon?
Give a very brief answer. 1.08e+1. What is the difference between the highest and the lowest Amount of goods traded (in US$) in Sudan?
Offer a very short reply. 1.73e+09. 